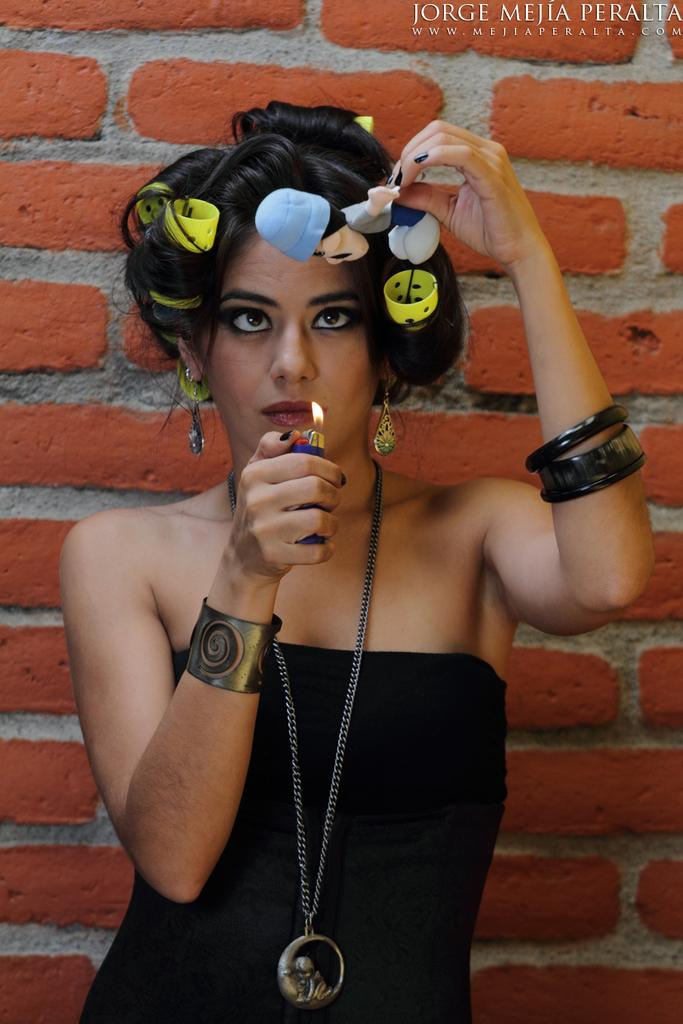What is the main subject of the image? There is a person in the image. What is the person wearing? The person is wearing a black dress and bangles. What is the person holding in her hands? The person is holding a lighter in her hands. What can be seen in the background of the image? There is a brick wall in the background of the image. What type of popcorn is being served on the plane in the image? There is no plane or popcorn present in the image; it features a person holding a lighter in front of a brick wall. 